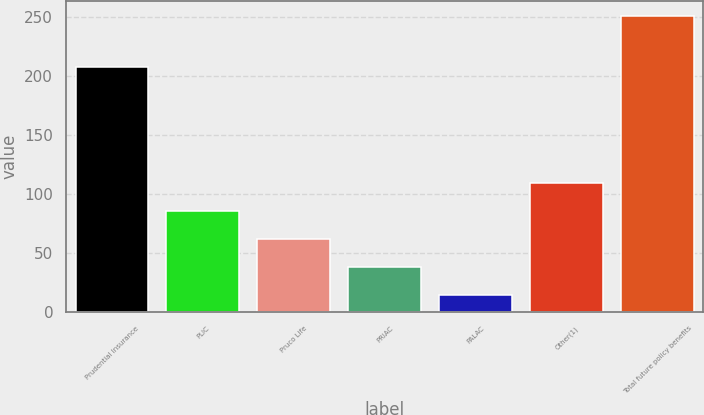Convert chart. <chart><loc_0><loc_0><loc_500><loc_500><bar_chart><fcel>Prudential Insurance<fcel>PLIC<fcel>Pruco Life<fcel>PRIAC<fcel>PALAC<fcel>Other(1)<fcel>Total future policy benefits<nl><fcel>207<fcel>85.47<fcel>61.88<fcel>38.29<fcel>14.7<fcel>109.06<fcel>250.6<nl></chart> 